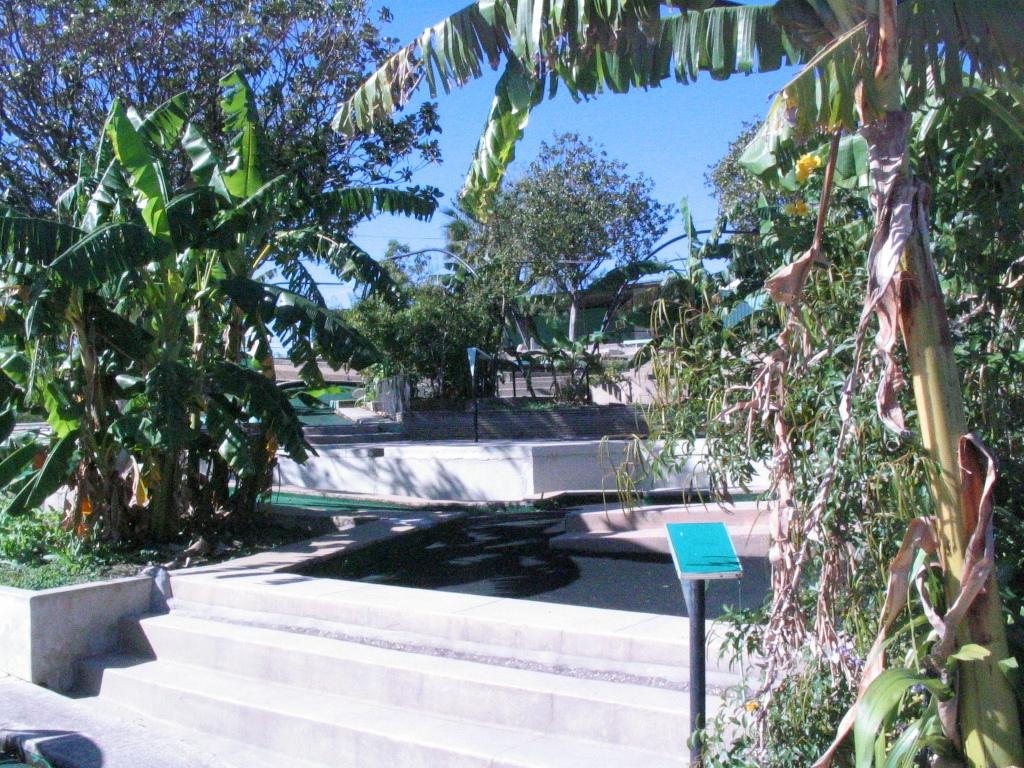What type of vegetation can be seen in the image? There are trees in the image. What architectural feature is present in the image? There are steps in the image. What color is the object in the image? The object in the image is blue. What can be seen in the background of the image? The sky is visible in the background of the image. What type of ground surface is present in the image? There is grass in the image. What type of knife can be seen in the image? There is no knife present in the image. What is being carried in the sack in the image? There is no sack present in the image. 